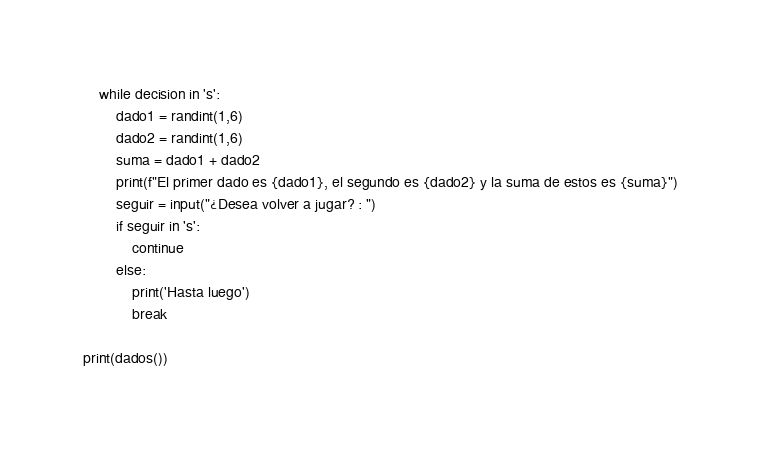<code> <loc_0><loc_0><loc_500><loc_500><_Python_>    while decision in 's':
        dado1 = randint(1,6)
        dado2 = randint(1,6)
        suma = dado1 + dado2
        print(f"El primer dado es {dado1}, el segundo es {dado2} y la suma de estos es {suma}")
        seguir = input("¿Desea volver a jugar? : ")
        if seguir in 's':
            continue
        else:
            print('Hasta luego')
            break

print(dados())</code> 